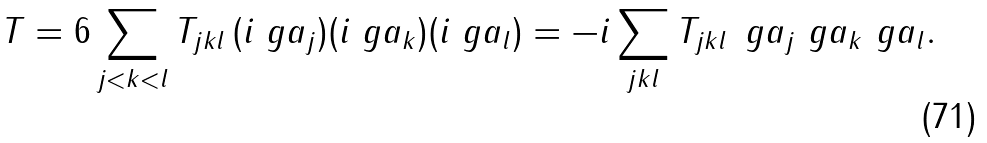Convert formula to latex. <formula><loc_0><loc_0><loc_500><loc_500>T = 6 \sum _ { j < k < l } T _ { j k l } \, ( i \ g a _ { j } ) ( i \ g a _ { k } ) ( i \ g a _ { l } ) = - i \sum _ { j k l } T _ { j k l } \, \ g a _ { j } \ g a _ { k } \ g a _ { l } .</formula> 